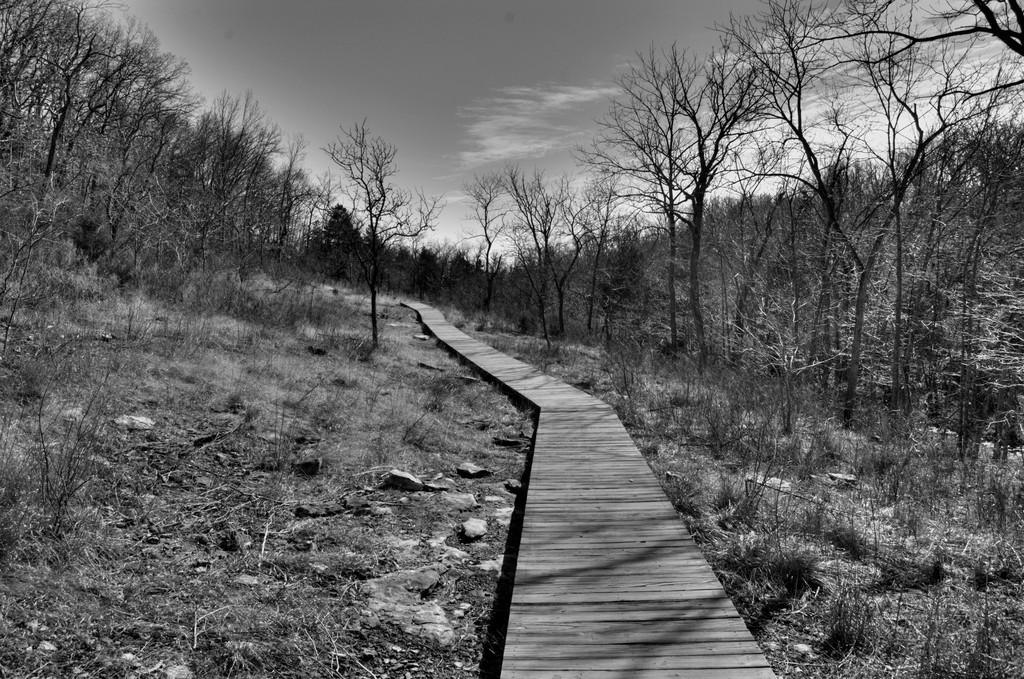What is the color scheme of the image? The image is black and white. What type of vegetation can be seen in the image? There are dry trees in the image. What else is present in the image besides the trees? There is grass and a pathway in the image. What is visible at the top of the image? The sky is visible at the top of the image. Can you tell me what time it is on the clock in the image? There is no clock present in the image. How many ladybugs can be seen on the dry trees in the image? There are no ladybugs visible in the image; it only features dry trees. 